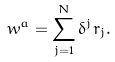<formula> <loc_0><loc_0><loc_500><loc_500>w ^ { a } = \sum _ { j = 1 } ^ { N } \delta ^ { j } r _ { j } .</formula> 